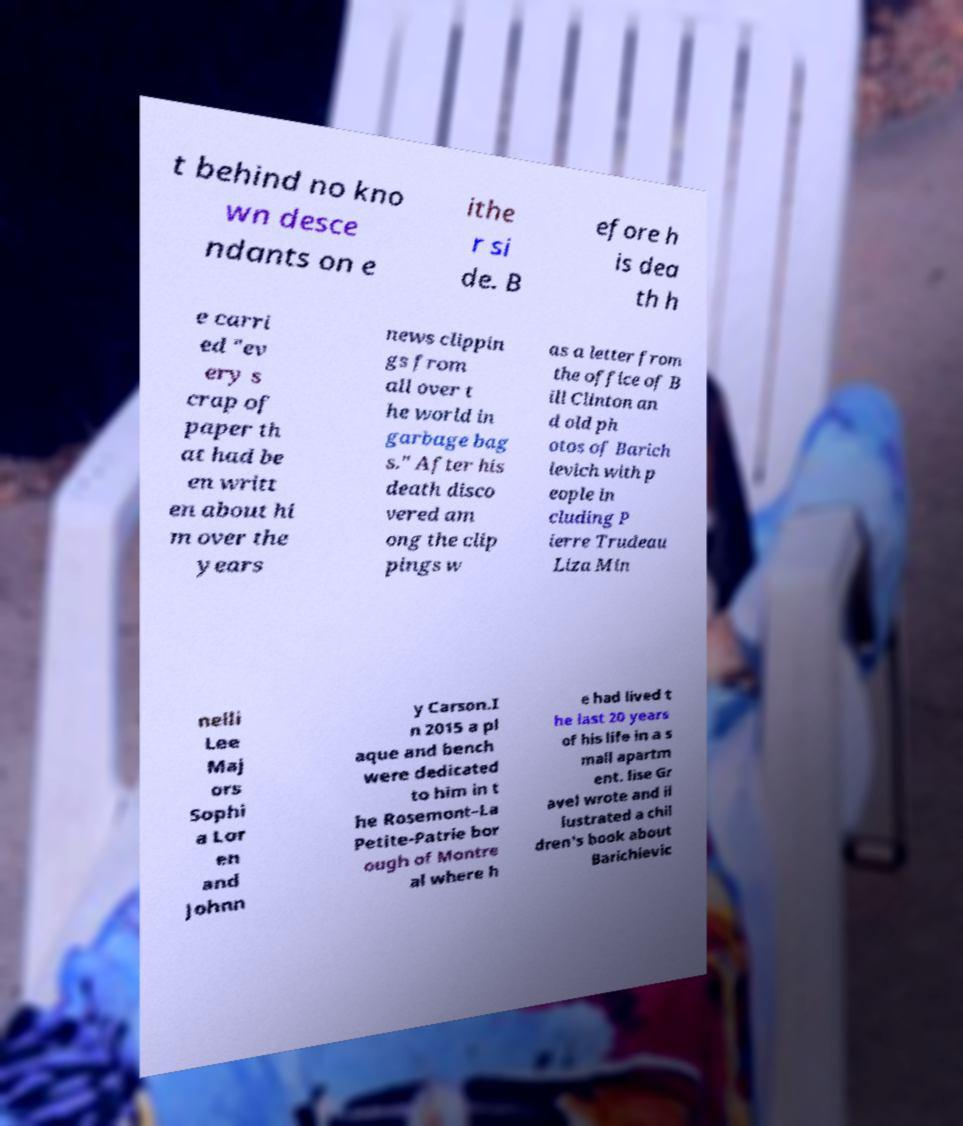Could you assist in decoding the text presented in this image and type it out clearly? t behind no kno wn desce ndants on e ithe r si de. B efore h is dea th h e carri ed "ev ery s crap of paper th at had be en writt en about hi m over the years news clippin gs from all over t he world in garbage bag s." After his death disco vered am ong the clip pings w as a letter from the office of B ill Clinton an d old ph otos of Barich ievich with p eople in cluding P ierre Trudeau Liza Min nelli Lee Maj ors Sophi a Lor en and Johnn y Carson.I n 2015 a pl aque and bench were dedicated to him in t he Rosemont–La Petite-Patrie bor ough of Montre al where h e had lived t he last 20 years of his life in a s mall apartm ent. lise Gr avel wrote and il lustrated a chil dren's book about Barichievic 